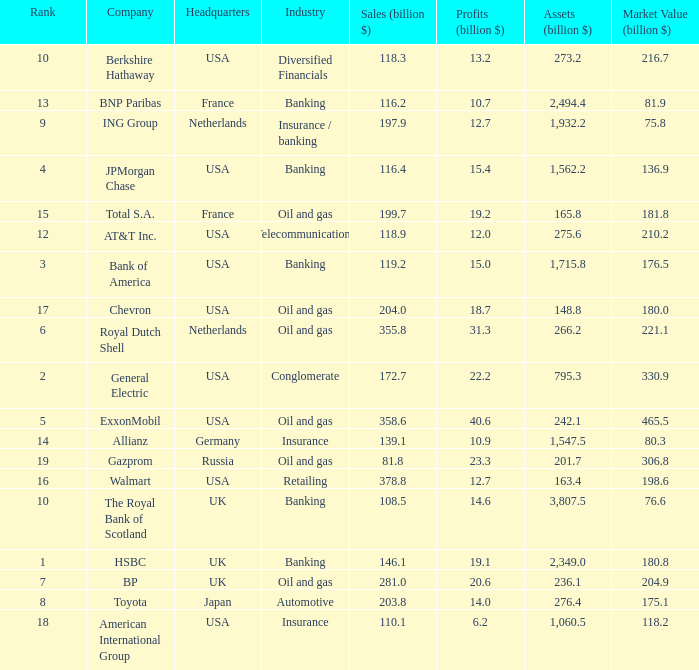Which industry has a company with a market value of 80.3 billion?  Insurance. 